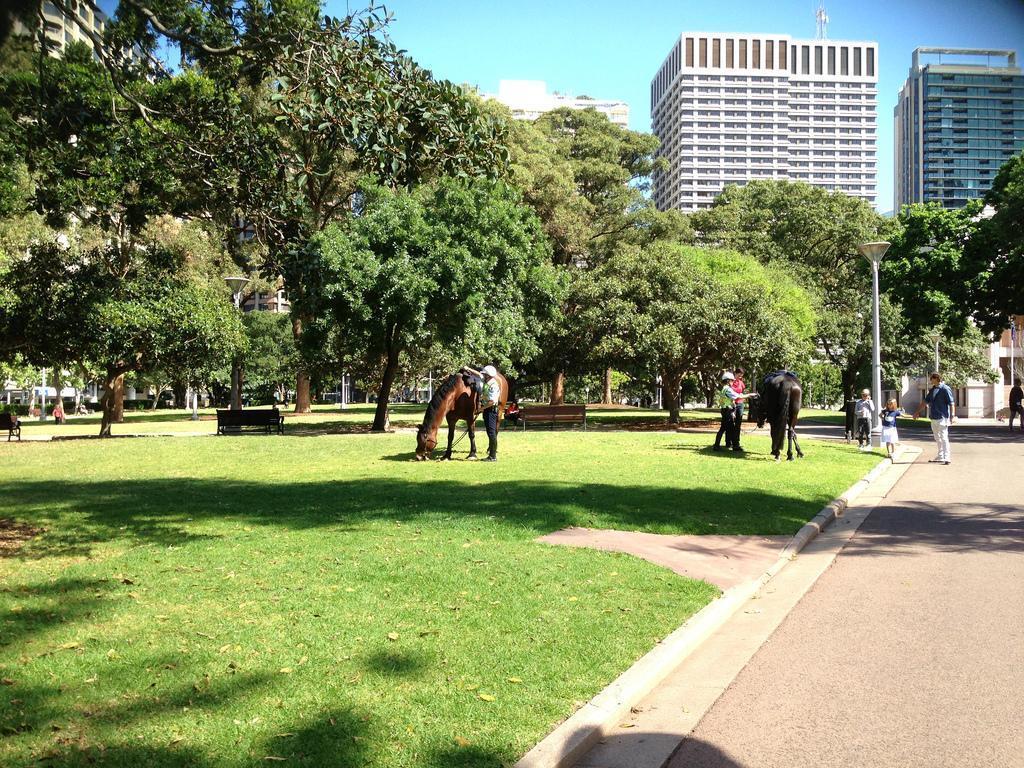How many horses are there?
Give a very brief answer. 2. How many benches are pictured?
Give a very brief answer. 2. 